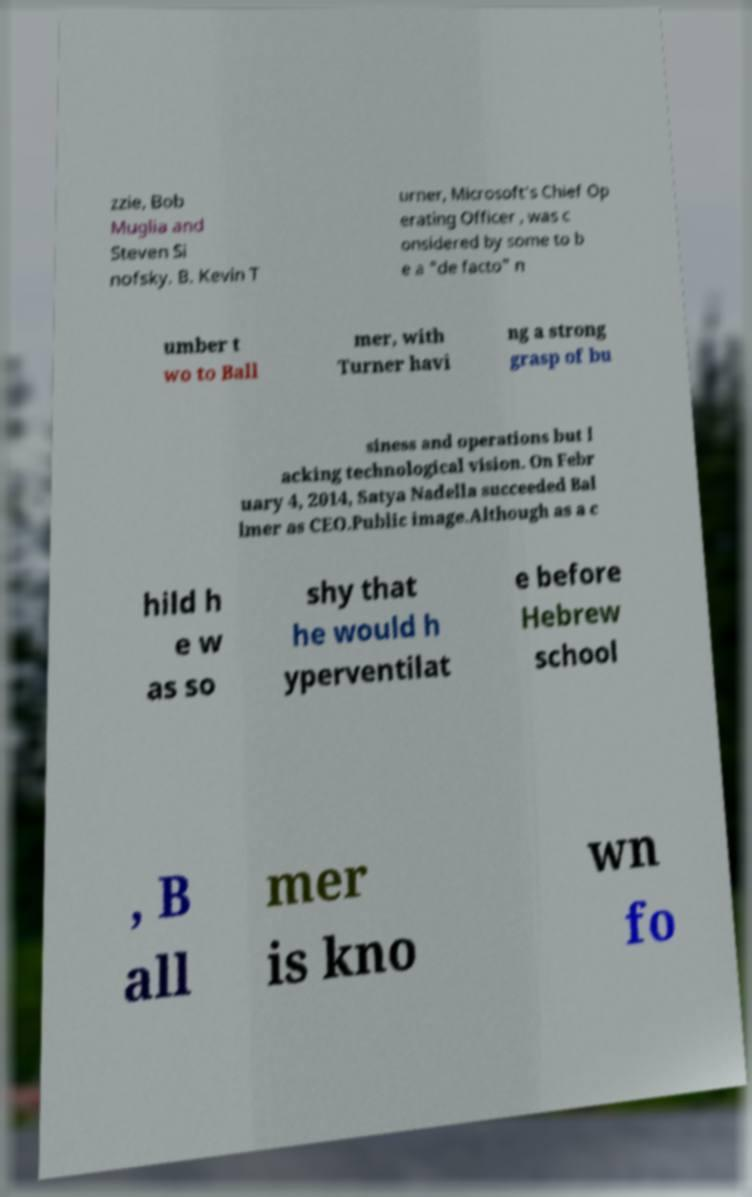Could you assist in decoding the text presented in this image and type it out clearly? zzie, Bob Muglia and Steven Si nofsky. B. Kevin T urner, Microsoft's Chief Op erating Officer , was c onsidered by some to b e a "de facto" n umber t wo to Ball mer, with Turner havi ng a strong grasp of bu siness and operations but l acking technological vision. On Febr uary 4, 2014, Satya Nadella succeeded Bal lmer as CEO.Public image.Although as a c hild h e w as so shy that he would h yperventilat e before Hebrew school , B all mer is kno wn fo 